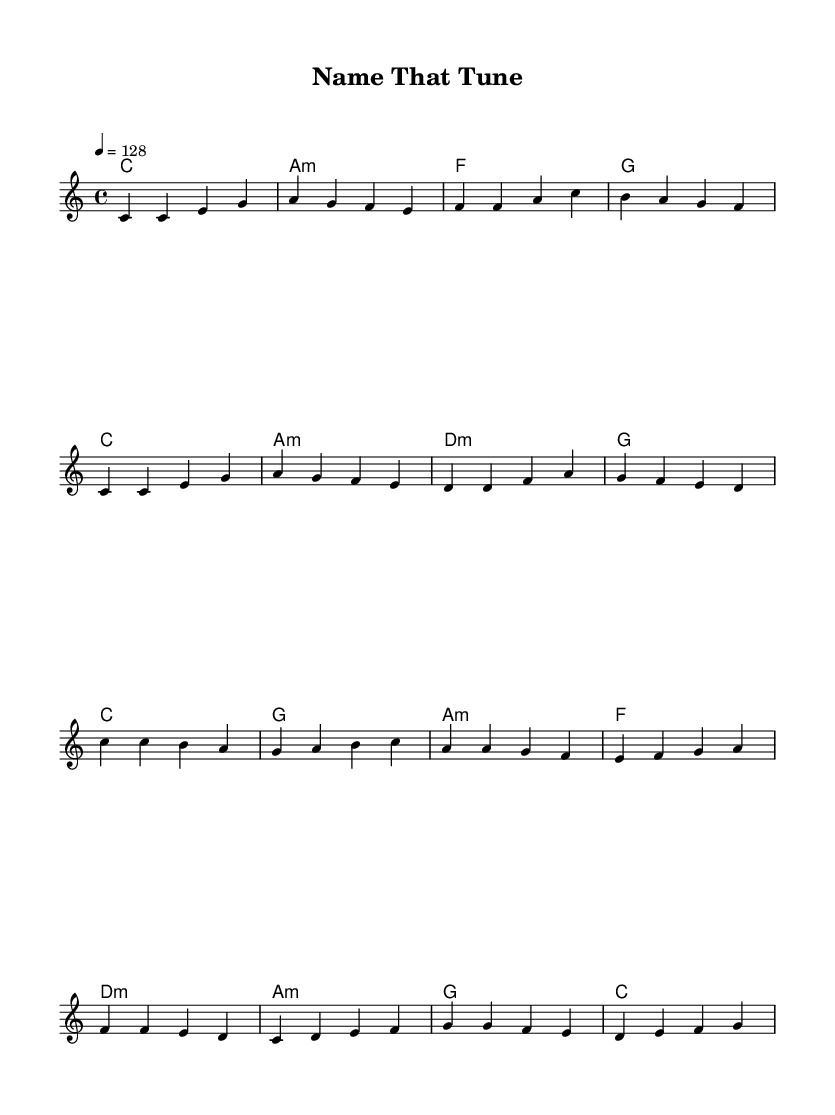What is the key signature of this music? The key signature is C major, which has no sharps or flats.
Answer: C major What is the time signature of this music? The time signature shows a 4/4 pattern, indicating four beats per measure.
Answer: 4/4 What is the tempo marking of this piece? The tempo marking indicates "4 = 128," meaning there are 128 beats per minute.
Answer: 128 Which chord is played at the beginning of the verse? The first chord in the verse is C major, as shown in the chord section of the sheet music.
Answer: C How many lines are there in the chorus lyrics? The chorus lyrics are presented in four lines based on how they are grouped in the sheet music.
Answer: Four lines What is the second word in the first chorus line? The second word in the first line of the chorus is "make." To find it, read the lyrics segment for that line.
Answer: make Why is the title "Name That Tune" appropriate for this piece? The title reflects the use of name-based puns in the lyrics, cleverly incorporating various names into the song context, which fits the playful theme of inviting listeners to engage with the music.
Answer: Engaging with names 